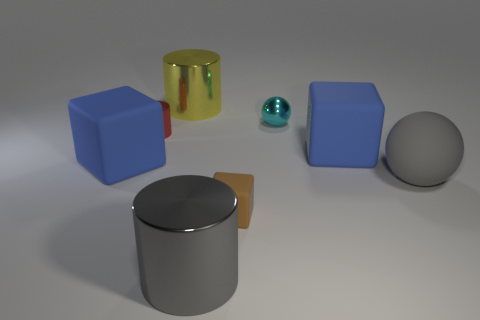Add 1 big yellow things. How many objects exist? 9 Subtract all spheres. How many objects are left? 6 Add 6 yellow rubber cylinders. How many yellow rubber cylinders exist? 6 Subtract 0 gray blocks. How many objects are left? 8 Subtract all big blue cubes. Subtract all tiny balls. How many objects are left? 5 Add 5 metal spheres. How many metal spheres are left? 6 